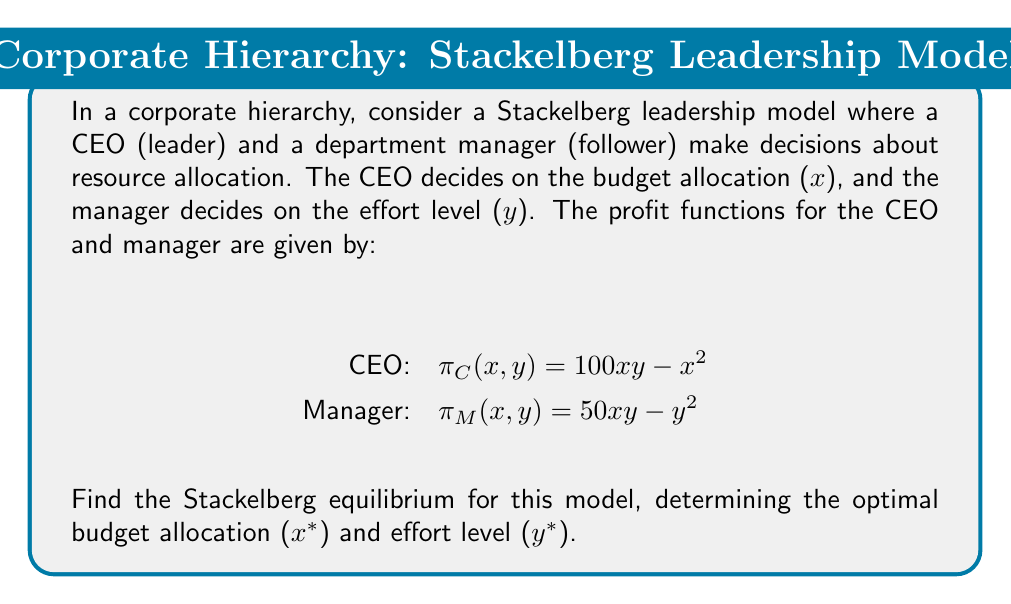Solve this math problem. To solve for the Stackelberg equilibrium, we use backward induction:

1. First, we determine the manager's best response function:
   - The manager maximizes $\pi_M(x,y) = 50xy - y^2$
   - Taking the derivative with respect to $y$: $\frac{\partial \pi_M}{\partial y} = 50x - 2y$
   - Setting this equal to zero: $50x - 2y = 0$
   - Solving for $y$: $y = 25x$

2. Now, we substitute the manager's best response into the CEO's profit function:
   $\pi_C(x) = 100x(25x) - x^2 = 2500x^2 - x^2 = 2499x^2$

3. The CEO maximizes this function:
   - Taking the derivative: $\frac{d\pi_C}{dx} = 4998x$
   - Setting this equal to zero: $4998x = 0$
   - Solving for $x$: $x^* = 0$

4. However, this solution is not meaningful in the context. The CEO would not allocate zero budget. We need to consider the constraint that $x > 0$.

5. Given that $\frac{d\pi_C}{dx} > 0$ for all $x > 0$, the CEO's profit increases with $x$. In practice, there would be an upper limit on the budget. Let's assume the maximum budget is 100 units.

6. Therefore, the optimal strategy for the CEO is to allocate the maximum budget: $x^* = 100$

7. We can now determine the manager's optimal effort by substituting $x^*$ into the best response function:
   $y^* = 25x^* = 25(100) = 2500$
Answer: The Stackelberg equilibrium is:
CEO's optimal budget allocation: $x^* = 100$
Manager's optimal effort level: $y^* = 2500$ 